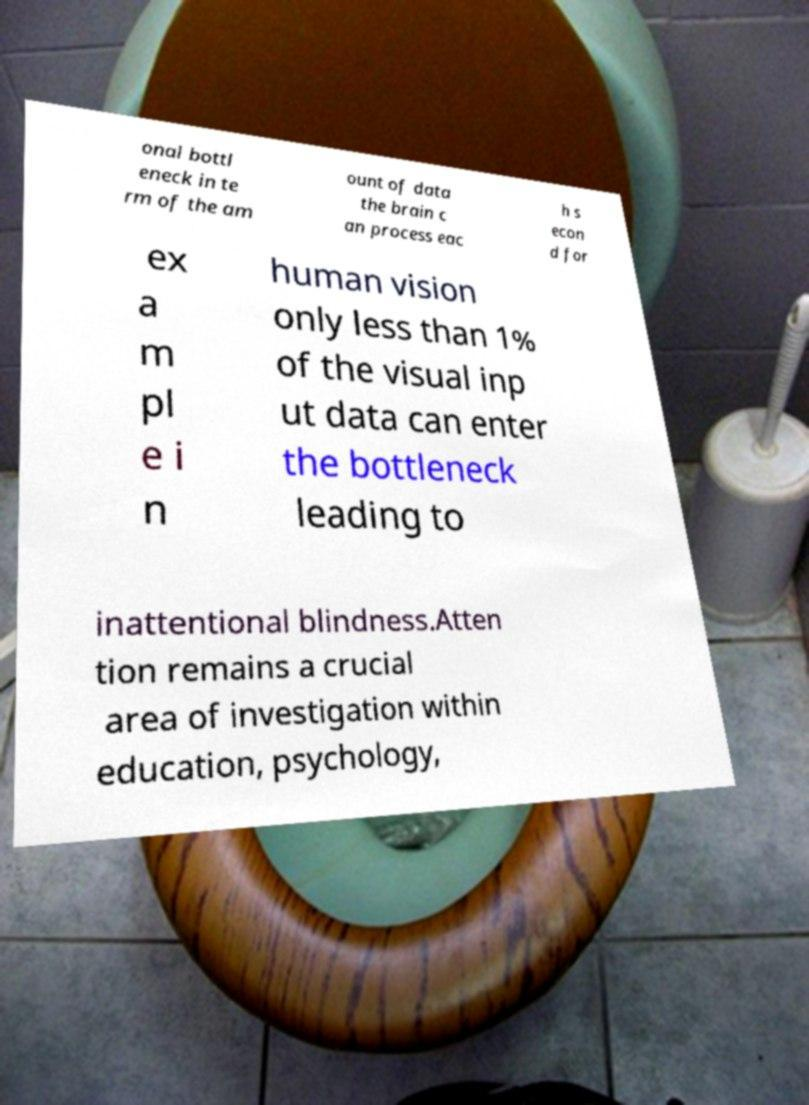Please read and relay the text visible in this image. What does it say? onal bottl eneck in te rm of the am ount of data the brain c an process eac h s econ d for ex a m pl e i n human vision only less than 1% of the visual inp ut data can enter the bottleneck leading to inattentional blindness.Atten tion remains a crucial area of investigation within education, psychology, 